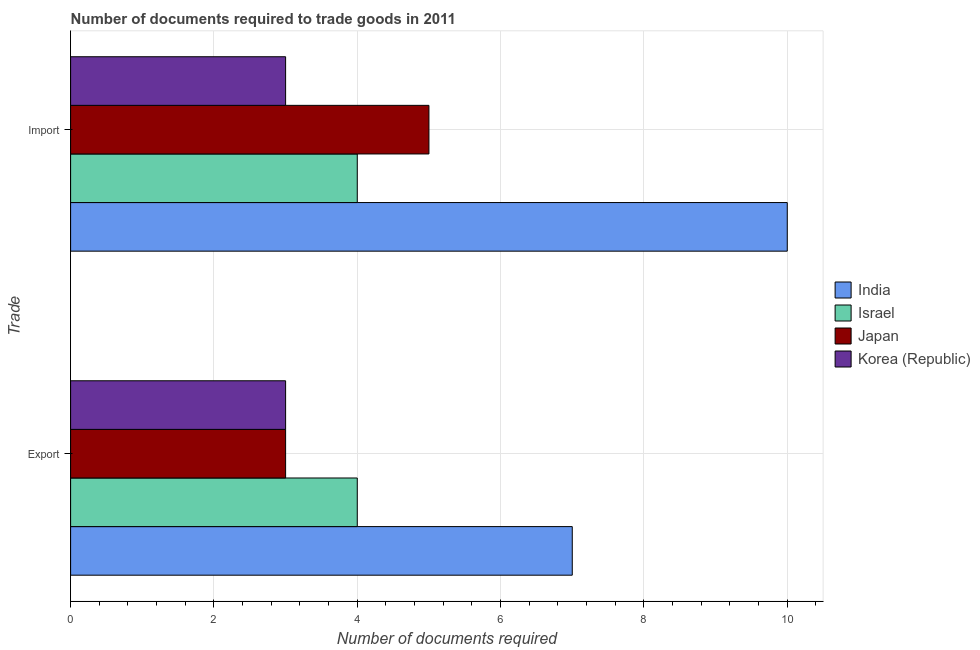Are the number of bars per tick equal to the number of legend labels?
Your response must be concise. Yes. Are the number of bars on each tick of the Y-axis equal?
Offer a very short reply. Yes. How many bars are there on the 1st tick from the bottom?
Give a very brief answer. 4. What is the label of the 2nd group of bars from the top?
Give a very brief answer. Export. What is the number of documents required to export goods in India?
Keep it short and to the point. 7. Across all countries, what is the maximum number of documents required to import goods?
Provide a short and direct response. 10. Across all countries, what is the minimum number of documents required to export goods?
Provide a short and direct response. 3. In which country was the number of documents required to import goods maximum?
Offer a very short reply. India. What is the total number of documents required to export goods in the graph?
Ensure brevity in your answer.  17. What is the difference between the number of documents required to import goods in Israel and that in India?
Offer a very short reply. -6. What is the difference between the number of documents required to import goods in India and the number of documents required to export goods in Korea (Republic)?
Your response must be concise. 7. What is the average number of documents required to export goods per country?
Provide a succinct answer. 4.25. What is the difference between the number of documents required to export goods and number of documents required to import goods in India?
Give a very brief answer. -3. What does the 4th bar from the top in Import represents?
Offer a terse response. India. What does the 2nd bar from the bottom in Export represents?
Give a very brief answer. Israel. How many bars are there?
Offer a very short reply. 8. What is the difference between two consecutive major ticks on the X-axis?
Ensure brevity in your answer.  2. Does the graph contain any zero values?
Your answer should be very brief. No. Where does the legend appear in the graph?
Make the answer very short. Center right. How many legend labels are there?
Offer a terse response. 4. How are the legend labels stacked?
Offer a terse response. Vertical. What is the title of the graph?
Offer a terse response. Number of documents required to trade goods in 2011. Does "Puerto Rico" appear as one of the legend labels in the graph?
Make the answer very short. No. What is the label or title of the X-axis?
Give a very brief answer. Number of documents required. What is the label or title of the Y-axis?
Make the answer very short. Trade. What is the Number of documents required of Israel in Export?
Your answer should be compact. 4. What is the Number of documents required of Korea (Republic) in Import?
Keep it short and to the point. 3. What is the total Number of documents required in Israel in the graph?
Your answer should be very brief. 8. What is the total Number of documents required in Japan in the graph?
Ensure brevity in your answer.  8. What is the difference between the Number of documents required of India in Export and that in Import?
Provide a short and direct response. -3. What is the difference between the Number of documents required in Japan in Export and that in Import?
Keep it short and to the point. -2. What is the difference between the Number of documents required in Korea (Republic) in Export and that in Import?
Offer a very short reply. 0. What is the difference between the Number of documents required of Israel in Export and the Number of documents required of Japan in Import?
Provide a succinct answer. -1. What is the average Number of documents required of India per Trade?
Your response must be concise. 8.5. What is the average Number of documents required in Israel per Trade?
Offer a terse response. 4. What is the average Number of documents required in Korea (Republic) per Trade?
Provide a short and direct response. 3. What is the difference between the Number of documents required of India and Number of documents required of Korea (Republic) in Export?
Provide a succinct answer. 4. What is the difference between the Number of documents required of India and Number of documents required of Japan in Import?
Give a very brief answer. 5. What is the difference between the Number of documents required of Japan and Number of documents required of Korea (Republic) in Import?
Your answer should be very brief. 2. What is the ratio of the Number of documents required of Israel in Export to that in Import?
Your answer should be very brief. 1. What is the difference between the highest and the second highest Number of documents required in Israel?
Ensure brevity in your answer.  0. What is the difference between the highest and the lowest Number of documents required in India?
Provide a succinct answer. 3. What is the difference between the highest and the lowest Number of documents required in Israel?
Keep it short and to the point. 0. 